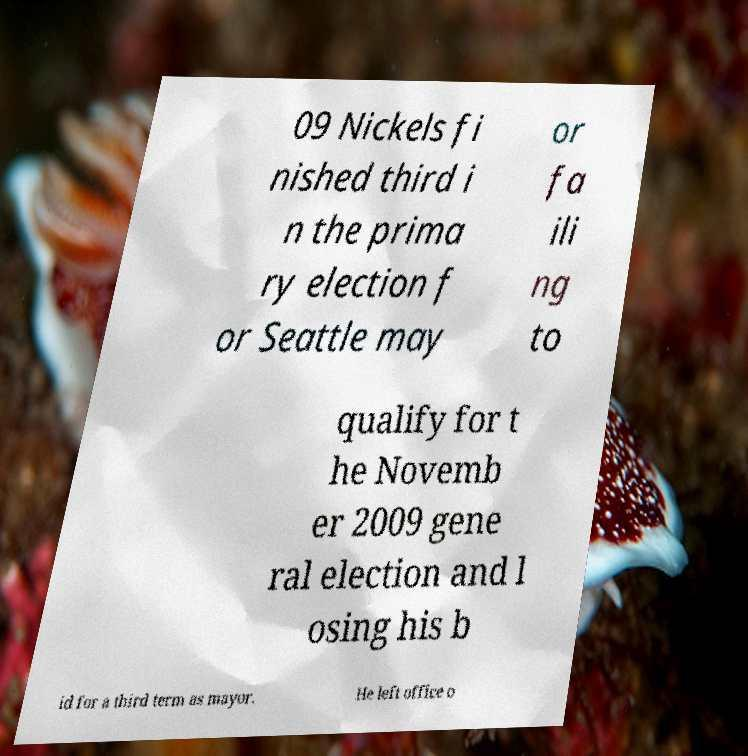Can you accurately transcribe the text from the provided image for me? 09 Nickels fi nished third i n the prima ry election f or Seattle may or fa ili ng to qualify for t he Novemb er 2009 gene ral election and l osing his b id for a third term as mayor. He left office o 